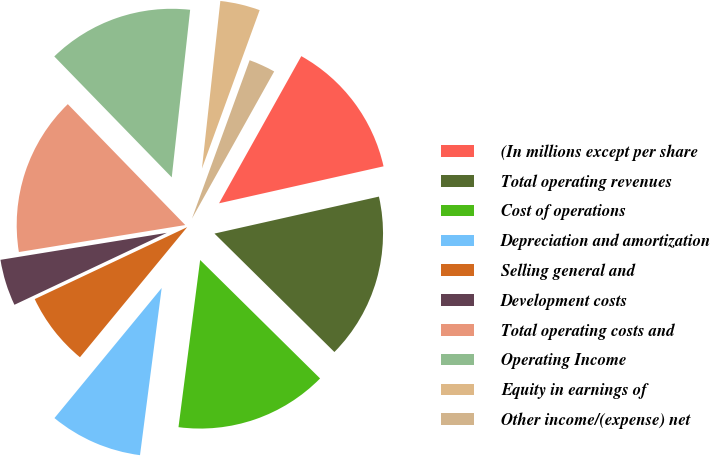<chart> <loc_0><loc_0><loc_500><loc_500><pie_chart><fcel>(In millions except per share<fcel>Total operating revenues<fcel>Cost of operations<fcel>Depreciation and amortization<fcel>Selling general and<fcel>Development costs<fcel>Total operating costs and<fcel>Operating Income<fcel>Equity in earnings of<fcel>Other income/(expense) net<nl><fcel>13.37%<fcel>15.92%<fcel>14.65%<fcel>8.92%<fcel>7.01%<fcel>4.46%<fcel>15.29%<fcel>14.01%<fcel>3.82%<fcel>2.55%<nl></chart> 